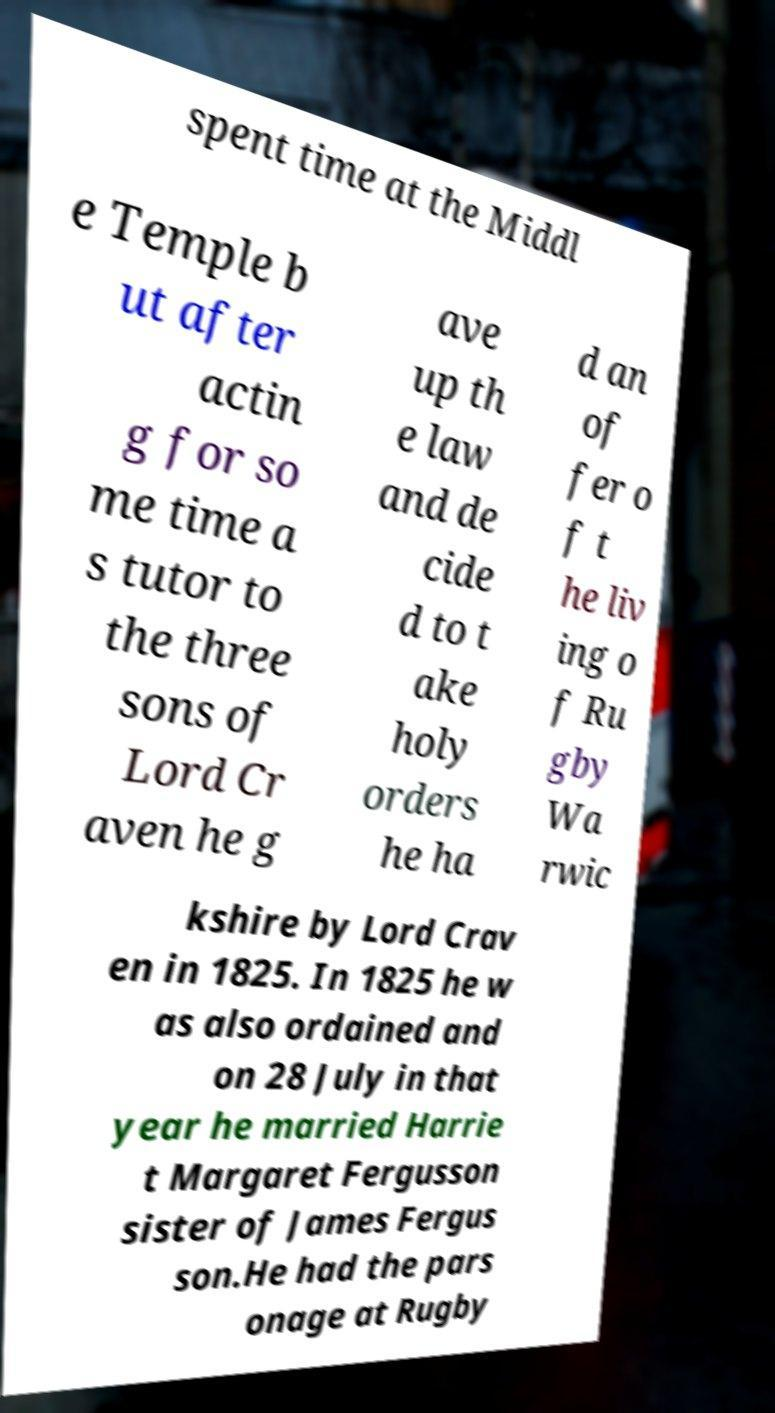What messages or text are displayed in this image? I need them in a readable, typed format. spent time at the Middl e Temple b ut after actin g for so me time a s tutor to the three sons of Lord Cr aven he g ave up th e law and de cide d to t ake holy orders he ha d an of fer o f t he liv ing o f Ru gby Wa rwic kshire by Lord Crav en in 1825. In 1825 he w as also ordained and on 28 July in that year he married Harrie t Margaret Fergusson sister of James Fergus son.He had the pars onage at Rugby 